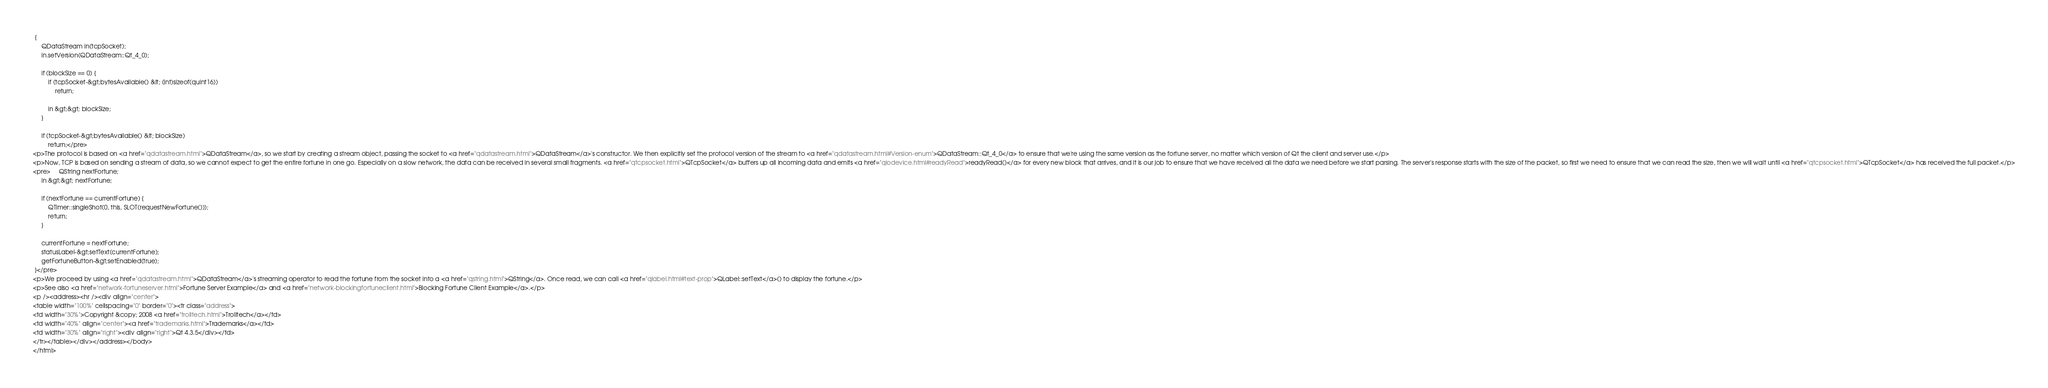Convert code to text. <code><loc_0><loc_0><loc_500><loc_500><_HTML_> {
     QDataStream in(tcpSocket);
     in.setVersion(QDataStream::Qt_4_0);

     if (blockSize == 0) {
         if (tcpSocket-&gt;bytesAvailable() &lt; (int)sizeof(quint16))
             return;

         in &gt;&gt; blockSize;
     }

     if (tcpSocket-&gt;bytesAvailable() &lt; blockSize)
         return;</pre>
<p>The protocol is based on <a href="qdatastream.html">QDataStream</a>, so we start by creating a stream object, passing the socket to <a href="qdatastream.html">QDataStream</a>'s constructor. We then explicitly set the protocol version of the stream to <a href="qdatastream.html#Version-enum">QDataStream::Qt_4_0</a> to ensure that we're using the same version as the fortune server, no matter which version of Qt the client and server use.</p>
<p>Now, TCP is based on sending a stream of data, so we cannot expect to get the entire fortune in one go. Especially on a slow network, the data can be received in several small fragments. <a href="qtcpsocket.html">QTcpSocket</a> buffers up all incoming data and emits <a href="qiodevice.html#readyRead">readyRead()</a> for every new block that arrives, and it is our job to ensure that we have received all the data we need before we start parsing. The server's response starts with the size of the packet, so first we need to ensure that we can read the size, then we will wait until <a href="qtcpsocket.html">QTcpSocket</a> has received the full packet.</p>
<pre>     QString nextFortune;
     in &gt;&gt; nextFortune;

     if (nextFortune == currentFortune) {
         QTimer::singleShot(0, this, SLOT(requestNewFortune()));
         return;
     }

     currentFortune = nextFortune;
     statusLabel-&gt;setText(currentFortune);
     getFortuneButton-&gt;setEnabled(true);
 }</pre>
<p>We proceed by using <a href="qdatastream.html">QDataStream</a>'s streaming operator to read the fortune from the socket into a <a href="qstring.html">QString</a>. Once read, we can call <a href="qlabel.html#text-prop">QLabel::setText</a>() to display the fortune.</p>
<p>See also <a href="network-fortuneserver.html">Fortune Server Example</a> and <a href="network-blockingfortuneclient.html">Blocking Fortune Client Example</a>.</p>
<p /><address><hr /><div align="center">
<table width="100%" cellspacing="0" border="0"><tr class="address">
<td width="30%">Copyright &copy; 2008 <a href="trolltech.html">Trolltech</a></td>
<td width="40%" align="center"><a href="trademarks.html">Trademarks</a></td>
<td width="30%" align="right"><div align="right">Qt 4.3.5</div></td>
</tr></table></div></address></body>
</html>
</code> 